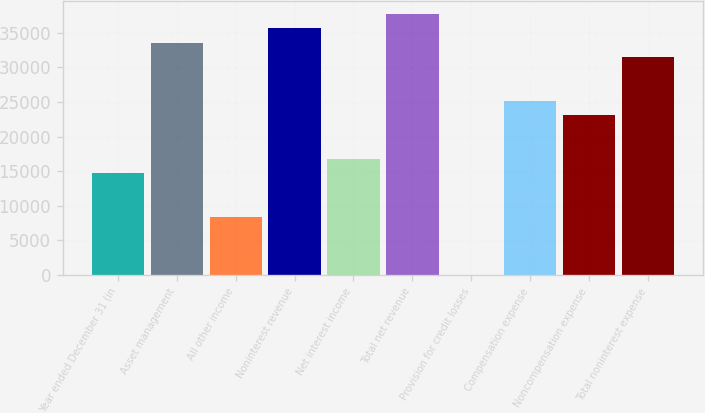Convert chart. <chart><loc_0><loc_0><loc_500><loc_500><bar_chart><fcel>Year ended December 31 (in<fcel>Asset management<fcel>All other income<fcel>Noninterest revenue<fcel>Net interest income<fcel>Total net revenue<fcel>Provision for credit losses<fcel>Compensation expense<fcel>Noncompensation expense<fcel>Total noninterest expense<nl><fcel>14683.7<fcel>33557.6<fcel>8392.4<fcel>35654.7<fcel>16780.8<fcel>37751.8<fcel>4<fcel>25169.2<fcel>23072.1<fcel>31460.5<nl></chart> 